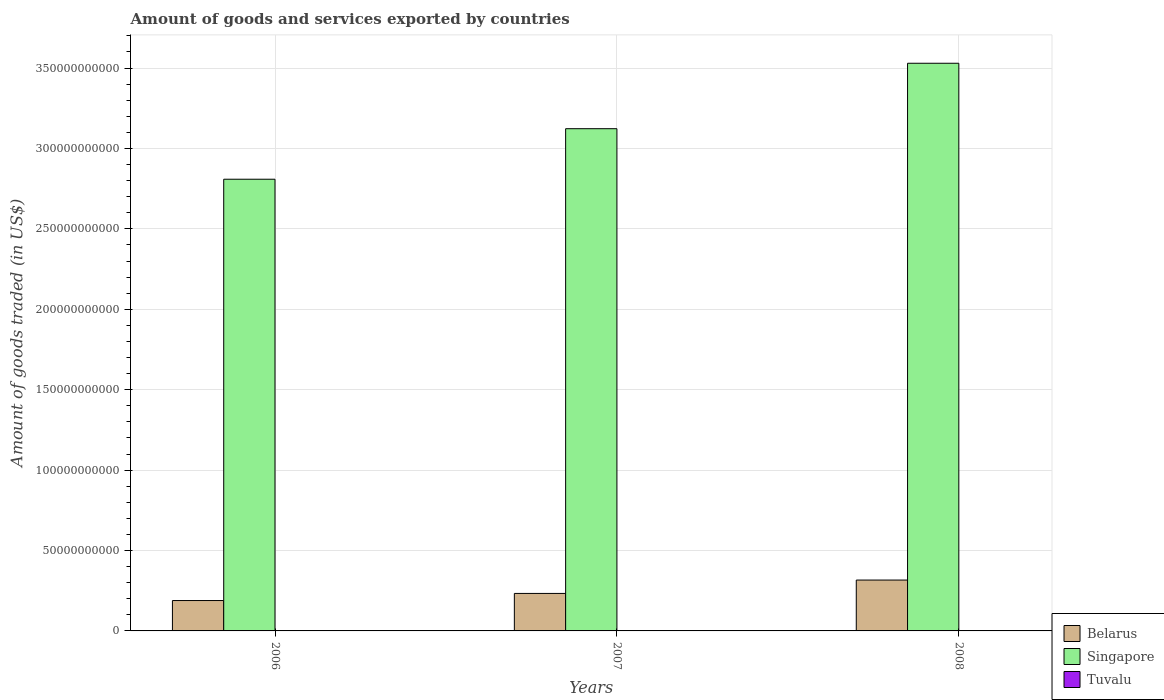How many different coloured bars are there?
Ensure brevity in your answer.  3. How many groups of bars are there?
Your response must be concise. 3. Are the number of bars per tick equal to the number of legend labels?
Make the answer very short. Yes. How many bars are there on the 2nd tick from the left?
Offer a very short reply. 3. How many bars are there on the 3rd tick from the right?
Your response must be concise. 3. What is the label of the 3rd group of bars from the left?
Your response must be concise. 2008. In how many cases, is the number of bars for a given year not equal to the number of legend labels?
Your response must be concise. 0. What is the total amount of goods and services exported in Singapore in 2008?
Offer a very short reply. 3.53e+11. Across all years, what is the maximum total amount of goods and services exported in Singapore?
Your answer should be compact. 3.53e+11. Across all years, what is the minimum total amount of goods and services exported in Belarus?
Ensure brevity in your answer.  1.89e+1. In which year was the total amount of goods and services exported in Belarus minimum?
Give a very brief answer. 2006. What is the total total amount of goods and services exported in Tuvalu in the graph?
Your answer should be very brief. 1.36e+06. What is the difference between the total amount of goods and services exported in Belarus in 2006 and that in 2008?
Provide a short and direct response. -1.27e+1. What is the difference between the total amount of goods and services exported in Singapore in 2007 and the total amount of goods and services exported in Tuvalu in 2008?
Offer a terse response. 3.12e+11. What is the average total amount of goods and services exported in Belarus per year?
Your response must be concise. 2.46e+1. In the year 2006, what is the difference between the total amount of goods and services exported in Singapore and total amount of goods and services exported in Belarus?
Provide a succinct answer. 2.62e+11. In how many years, is the total amount of goods and services exported in Singapore greater than 200000000000 US$?
Ensure brevity in your answer.  3. What is the ratio of the total amount of goods and services exported in Tuvalu in 2007 to that in 2008?
Your answer should be very brief. 0.74. What is the difference between the highest and the second highest total amount of goods and services exported in Singapore?
Make the answer very short. 4.07e+1. What is the difference between the highest and the lowest total amount of goods and services exported in Belarus?
Offer a terse response. 1.27e+1. What does the 2nd bar from the left in 2007 represents?
Your answer should be compact. Singapore. What does the 2nd bar from the right in 2007 represents?
Your answer should be very brief. Singapore. Is it the case that in every year, the sum of the total amount of goods and services exported in Belarus and total amount of goods and services exported in Tuvalu is greater than the total amount of goods and services exported in Singapore?
Ensure brevity in your answer.  No. How many bars are there?
Give a very brief answer. 9. Are all the bars in the graph horizontal?
Your response must be concise. No. What is the difference between two consecutive major ticks on the Y-axis?
Provide a succinct answer. 5.00e+1. Are the values on the major ticks of Y-axis written in scientific E-notation?
Your answer should be very brief. No. Does the graph contain any zero values?
Offer a terse response. No. Where does the legend appear in the graph?
Provide a succinct answer. Bottom right. What is the title of the graph?
Provide a succinct answer. Amount of goods and services exported by countries. What is the label or title of the Y-axis?
Your answer should be very brief. Amount of goods traded (in US$). What is the Amount of goods traded (in US$) in Belarus in 2006?
Your answer should be very brief. 1.89e+1. What is the Amount of goods traded (in US$) in Singapore in 2006?
Offer a very short reply. 2.81e+11. What is the Amount of goods traded (in US$) of Tuvalu in 2006?
Provide a succinct answer. 4.18e+05. What is the Amount of goods traded (in US$) of Belarus in 2007?
Give a very brief answer. 2.33e+1. What is the Amount of goods traded (in US$) of Singapore in 2007?
Your response must be concise. 3.12e+11. What is the Amount of goods traded (in US$) in Tuvalu in 2007?
Offer a terse response. 4.01e+05. What is the Amount of goods traded (in US$) of Belarus in 2008?
Keep it short and to the point. 3.16e+1. What is the Amount of goods traded (in US$) in Singapore in 2008?
Ensure brevity in your answer.  3.53e+11. What is the Amount of goods traded (in US$) in Tuvalu in 2008?
Offer a terse response. 5.43e+05. Across all years, what is the maximum Amount of goods traded (in US$) in Belarus?
Your answer should be compact. 3.16e+1. Across all years, what is the maximum Amount of goods traded (in US$) in Singapore?
Provide a short and direct response. 3.53e+11. Across all years, what is the maximum Amount of goods traded (in US$) of Tuvalu?
Offer a very short reply. 5.43e+05. Across all years, what is the minimum Amount of goods traded (in US$) in Belarus?
Offer a terse response. 1.89e+1. Across all years, what is the minimum Amount of goods traded (in US$) of Singapore?
Your answer should be compact. 2.81e+11. Across all years, what is the minimum Amount of goods traded (in US$) in Tuvalu?
Offer a terse response. 4.01e+05. What is the total Amount of goods traded (in US$) in Belarus in the graph?
Your response must be concise. 7.38e+1. What is the total Amount of goods traded (in US$) in Singapore in the graph?
Offer a very short reply. 9.46e+11. What is the total Amount of goods traded (in US$) of Tuvalu in the graph?
Your response must be concise. 1.36e+06. What is the difference between the Amount of goods traded (in US$) in Belarus in 2006 and that in 2007?
Ensure brevity in your answer.  -4.41e+09. What is the difference between the Amount of goods traded (in US$) in Singapore in 2006 and that in 2007?
Offer a very short reply. -3.14e+1. What is the difference between the Amount of goods traded (in US$) in Tuvalu in 2006 and that in 2007?
Offer a very short reply. 1.71e+04. What is the difference between the Amount of goods traded (in US$) of Belarus in 2006 and that in 2008?
Your response must be concise. -1.27e+1. What is the difference between the Amount of goods traded (in US$) of Singapore in 2006 and that in 2008?
Provide a succinct answer. -7.21e+1. What is the difference between the Amount of goods traded (in US$) in Tuvalu in 2006 and that in 2008?
Ensure brevity in your answer.  -1.25e+05. What is the difference between the Amount of goods traded (in US$) in Belarus in 2007 and that in 2008?
Give a very brief answer. -8.32e+09. What is the difference between the Amount of goods traded (in US$) of Singapore in 2007 and that in 2008?
Make the answer very short. -4.07e+1. What is the difference between the Amount of goods traded (in US$) in Tuvalu in 2007 and that in 2008?
Give a very brief answer. -1.42e+05. What is the difference between the Amount of goods traded (in US$) in Belarus in 2006 and the Amount of goods traded (in US$) in Singapore in 2007?
Your response must be concise. -2.93e+11. What is the difference between the Amount of goods traded (in US$) of Belarus in 2006 and the Amount of goods traded (in US$) of Tuvalu in 2007?
Ensure brevity in your answer.  1.89e+1. What is the difference between the Amount of goods traded (in US$) in Singapore in 2006 and the Amount of goods traded (in US$) in Tuvalu in 2007?
Provide a succinct answer. 2.81e+11. What is the difference between the Amount of goods traded (in US$) in Belarus in 2006 and the Amount of goods traded (in US$) in Singapore in 2008?
Ensure brevity in your answer.  -3.34e+11. What is the difference between the Amount of goods traded (in US$) in Belarus in 2006 and the Amount of goods traded (in US$) in Tuvalu in 2008?
Offer a very short reply. 1.89e+1. What is the difference between the Amount of goods traded (in US$) in Singapore in 2006 and the Amount of goods traded (in US$) in Tuvalu in 2008?
Ensure brevity in your answer.  2.81e+11. What is the difference between the Amount of goods traded (in US$) in Belarus in 2007 and the Amount of goods traded (in US$) in Singapore in 2008?
Keep it short and to the point. -3.30e+11. What is the difference between the Amount of goods traded (in US$) in Belarus in 2007 and the Amount of goods traded (in US$) in Tuvalu in 2008?
Keep it short and to the point. 2.33e+1. What is the difference between the Amount of goods traded (in US$) in Singapore in 2007 and the Amount of goods traded (in US$) in Tuvalu in 2008?
Offer a terse response. 3.12e+11. What is the average Amount of goods traded (in US$) in Belarus per year?
Your answer should be compact. 2.46e+1. What is the average Amount of goods traded (in US$) in Singapore per year?
Provide a succinct answer. 3.15e+11. What is the average Amount of goods traded (in US$) of Tuvalu per year?
Give a very brief answer. 4.54e+05. In the year 2006, what is the difference between the Amount of goods traded (in US$) in Belarus and Amount of goods traded (in US$) in Singapore?
Keep it short and to the point. -2.62e+11. In the year 2006, what is the difference between the Amount of goods traded (in US$) of Belarus and Amount of goods traded (in US$) of Tuvalu?
Give a very brief answer. 1.89e+1. In the year 2006, what is the difference between the Amount of goods traded (in US$) in Singapore and Amount of goods traded (in US$) in Tuvalu?
Provide a succinct answer. 2.81e+11. In the year 2007, what is the difference between the Amount of goods traded (in US$) in Belarus and Amount of goods traded (in US$) in Singapore?
Offer a very short reply. -2.89e+11. In the year 2007, what is the difference between the Amount of goods traded (in US$) of Belarus and Amount of goods traded (in US$) of Tuvalu?
Offer a terse response. 2.33e+1. In the year 2007, what is the difference between the Amount of goods traded (in US$) of Singapore and Amount of goods traded (in US$) of Tuvalu?
Provide a succinct answer. 3.12e+11. In the year 2008, what is the difference between the Amount of goods traded (in US$) in Belarus and Amount of goods traded (in US$) in Singapore?
Your answer should be very brief. -3.21e+11. In the year 2008, what is the difference between the Amount of goods traded (in US$) of Belarus and Amount of goods traded (in US$) of Tuvalu?
Your answer should be compact. 3.16e+1. In the year 2008, what is the difference between the Amount of goods traded (in US$) of Singapore and Amount of goods traded (in US$) of Tuvalu?
Ensure brevity in your answer.  3.53e+11. What is the ratio of the Amount of goods traded (in US$) of Belarus in 2006 to that in 2007?
Give a very brief answer. 0.81. What is the ratio of the Amount of goods traded (in US$) in Singapore in 2006 to that in 2007?
Make the answer very short. 0.9. What is the ratio of the Amount of goods traded (in US$) of Tuvalu in 2006 to that in 2007?
Offer a very short reply. 1.04. What is the ratio of the Amount of goods traded (in US$) in Belarus in 2006 to that in 2008?
Provide a short and direct response. 0.6. What is the ratio of the Amount of goods traded (in US$) of Singapore in 2006 to that in 2008?
Make the answer very short. 0.8. What is the ratio of the Amount of goods traded (in US$) of Tuvalu in 2006 to that in 2008?
Keep it short and to the point. 0.77. What is the ratio of the Amount of goods traded (in US$) in Belarus in 2007 to that in 2008?
Give a very brief answer. 0.74. What is the ratio of the Amount of goods traded (in US$) of Singapore in 2007 to that in 2008?
Give a very brief answer. 0.88. What is the ratio of the Amount of goods traded (in US$) in Tuvalu in 2007 to that in 2008?
Your response must be concise. 0.74. What is the difference between the highest and the second highest Amount of goods traded (in US$) of Belarus?
Your answer should be compact. 8.32e+09. What is the difference between the highest and the second highest Amount of goods traded (in US$) of Singapore?
Give a very brief answer. 4.07e+1. What is the difference between the highest and the second highest Amount of goods traded (in US$) in Tuvalu?
Your answer should be compact. 1.25e+05. What is the difference between the highest and the lowest Amount of goods traded (in US$) in Belarus?
Give a very brief answer. 1.27e+1. What is the difference between the highest and the lowest Amount of goods traded (in US$) of Singapore?
Your answer should be very brief. 7.21e+1. What is the difference between the highest and the lowest Amount of goods traded (in US$) of Tuvalu?
Offer a terse response. 1.42e+05. 